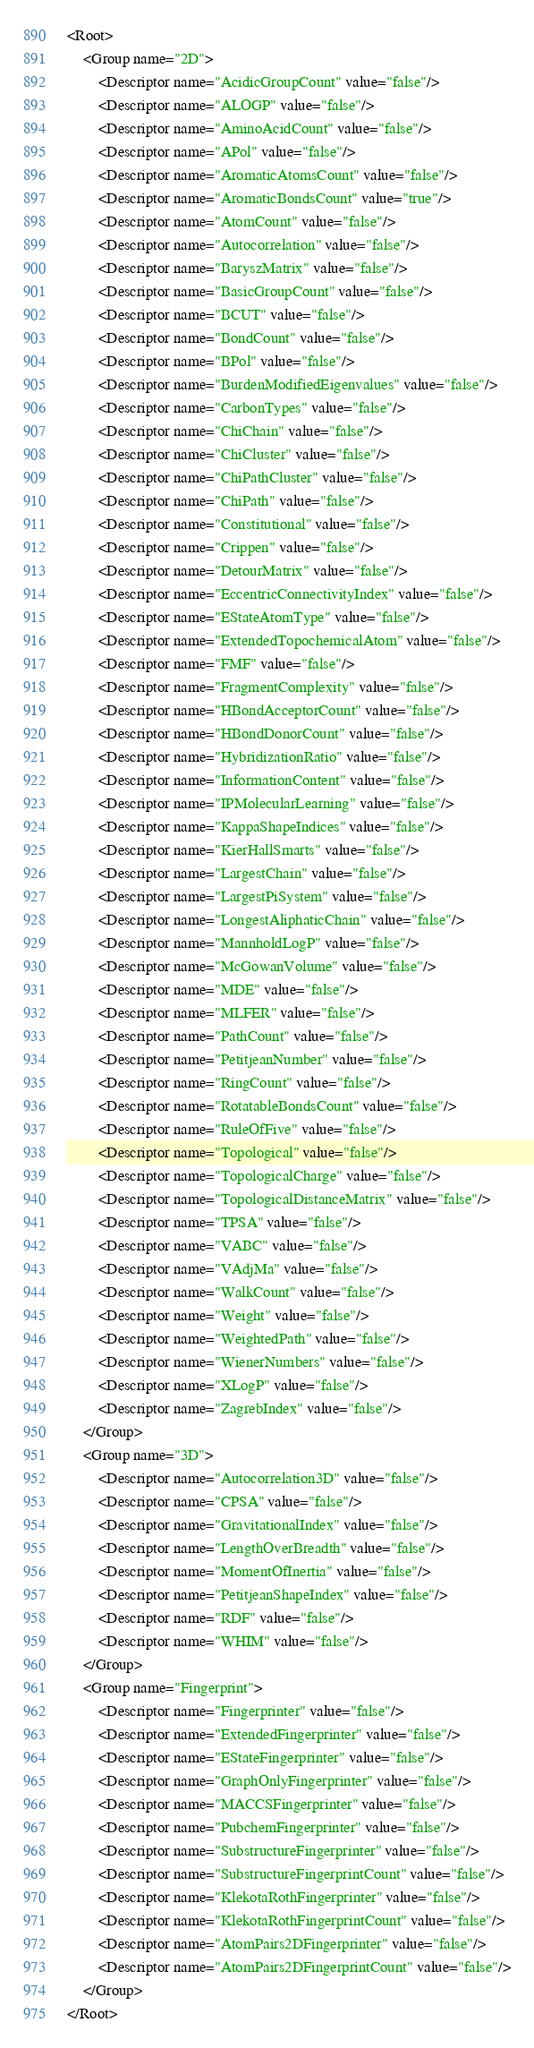<code> <loc_0><loc_0><loc_500><loc_500><_XML_><Root>
    <Group name="2D">
        <Descriptor name="AcidicGroupCount" value="false"/>
        <Descriptor name="ALOGP" value="false"/>
        <Descriptor name="AminoAcidCount" value="false"/>
        <Descriptor name="APol" value="false"/>
        <Descriptor name="AromaticAtomsCount" value="false"/>
        <Descriptor name="AromaticBondsCount" value="true"/>
        <Descriptor name="AtomCount" value="false"/>
        <Descriptor name="Autocorrelation" value="false"/>
        <Descriptor name="BaryszMatrix" value="false"/>
        <Descriptor name="BasicGroupCount" value="false"/>
        <Descriptor name="BCUT" value="false"/>
        <Descriptor name="BondCount" value="false"/>
        <Descriptor name="BPol" value="false"/>
        <Descriptor name="BurdenModifiedEigenvalues" value="false"/>
        <Descriptor name="CarbonTypes" value="false"/>
        <Descriptor name="ChiChain" value="false"/>
        <Descriptor name="ChiCluster" value="false"/>
        <Descriptor name="ChiPathCluster" value="false"/>
        <Descriptor name="ChiPath" value="false"/>
        <Descriptor name="Constitutional" value="false"/>
        <Descriptor name="Crippen" value="false"/>
        <Descriptor name="DetourMatrix" value="false"/>
        <Descriptor name="EccentricConnectivityIndex" value="false"/>
        <Descriptor name="EStateAtomType" value="false"/>
        <Descriptor name="ExtendedTopochemicalAtom" value="false"/>
        <Descriptor name="FMF" value="false"/>
        <Descriptor name="FragmentComplexity" value="false"/>
        <Descriptor name="HBondAcceptorCount" value="false"/>
        <Descriptor name="HBondDonorCount" value="false"/>
        <Descriptor name="HybridizationRatio" value="false"/>
        <Descriptor name="InformationContent" value="false"/>
        <Descriptor name="IPMolecularLearning" value="false"/>
        <Descriptor name="KappaShapeIndices" value="false"/>
        <Descriptor name="KierHallSmarts" value="false"/>
        <Descriptor name="LargestChain" value="false"/>
        <Descriptor name="LargestPiSystem" value="false"/>
        <Descriptor name="LongestAliphaticChain" value="false"/>
        <Descriptor name="MannholdLogP" value="false"/>
        <Descriptor name="McGowanVolume" value="false"/>
        <Descriptor name="MDE" value="false"/>
        <Descriptor name="MLFER" value="false"/>
        <Descriptor name="PathCount" value="false"/>
        <Descriptor name="PetitjeanNumber" value="false"/>
        <Descriptor name="RingCount" value="false"/>
        <Descriptor name="RotatableBondsCount" value="false"/>
        <Descriptor name="RuleOfFive" value="false"/>
        <Descriptor name="Topological" value="false"/>
        <Descriptor name="TopologicalCharge" value="false"/>
        <Descriptor name="TopologicalDistanceMatrix" value="false"/>
        <Descriptor name="TPSA" value="false"/>
        <Descriptor name="VABC" value="false"/>
        <Descriptor name="VAdjMa" value="false"/>
        <Descriptor name="WalkCount" value="false"/>
        <Descriptor name="Weight" value="false"/>
        <Descriptor name="WeightedPath" value="false"/>
        <Descriptor name="WienerNumbers" value="false"/>
        <Descriptor name="XLogP" value="false"/>
        <Descriptor name="ZagrebIndex" value="false"/>
    </Group>
    <Group name="3D">
        <Descriptor name="Autocorrelation3D" value="false"/>
        <Descriptor name="CPSA" value="false"/>
        <Descriptor name="GravitationalIndex" value="false"/>
        <Descriptor name="LengthOverBreadth" value="false"/>
        <Descriptor name="MomentOfInertia" value="false"/>
        <Descriptor name="PetitjeanShapeIndex" value="false"/>
        <Descriptor name="RDF" value="false"/>
        <Descriptor name="WHIM" value="false"/>
    </Group>
    <Group name="Fingerprint">
        <Descriptor name="Fingerprinter" value="false"/>
        <Descriptor name="ExtendedFingerprinter" value="false"/>
        <Descriptor name="EStateFingerprinter" value="false"/>
        <Descriptor name="GraphOnlyFingerprinter" value="false"/>
        <Descriptor name="MACCSFingerprinter" value="false"/>
        <Descriptor name="PubchemFingerprinter" value="false"/>
        <Descriptor name="SubstructureFingerprinter" value="false"/>
        <Descriptor name="SubstructureFingerprintCount" value="false"/>
        <Descriptor name="KlekotaRothFingerprinter" value="false"/>
        <Descriptor name="KlekotaRothFingerprintCount" value="false"/>
        <Descriptor name="AtomPairs2DFingerprinter" value="false"/>
        <Descriptor name="AtomPairs2DFingerprintCount" value="false"/>
    </Group>
</Root></code> 